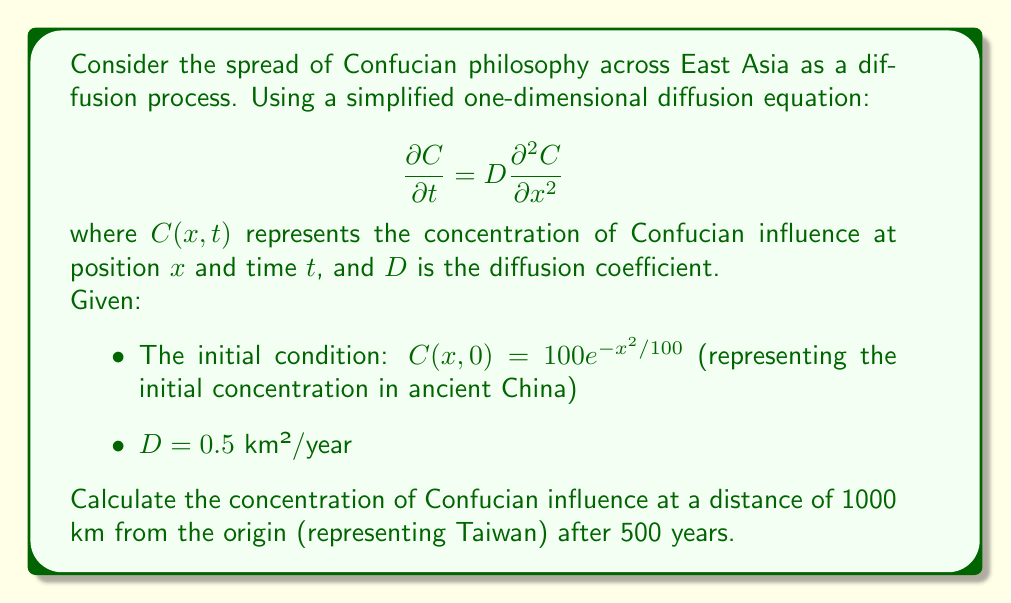Give your solution to this math problem. To solve this problem, we'll use the solution to the one-dimensional diffusion equation with an initial Gaussian distribution:

1) The general solution for this case is:

   $$C(x,t) = \frac{M}{\sqrt{4\pi Dt + \sigma^2}} e^{-\frac{x^2}{4Dt + \sigma^2}}$$

   where $M$ is the total amount of substance and $\sigma^2$ is the initial variance.

2) From the initial condition, we can identify:
   $\sigma^2 = 50$ (half of the coefficient in the exponent)
   $M = 100\sqrt{50\pi}$ (to make the initial condition integrate to this value)

3) Substituting the given values:
   $D = 0.5$ km²/year
   $t = 500$ years
   $x = 1000$ km

4) Let's calculate $4Dt + \sigma^2$:
   $4Dt + \sigma^2 = 4(0.5)(500) + 50 = 1050$

5) Now we can substitute everything into the solution:

   $$C(1000, 500) = \frac{100\sqrt{50\pi}}{\sqrt{1050\pi}} e^{-\frac{1000^2}{1050}}$$

6) Simplifying:
   
   $$C(1000, 500) = \frac{100\sqrt{50}}{\sqrt{1050}} e^{-\frac{1000000}{1050}} \approx 0.6839$$

The concentration is approximately 0.6839 units at 1000 km after 500 years.
Answer: 0.6839 units 